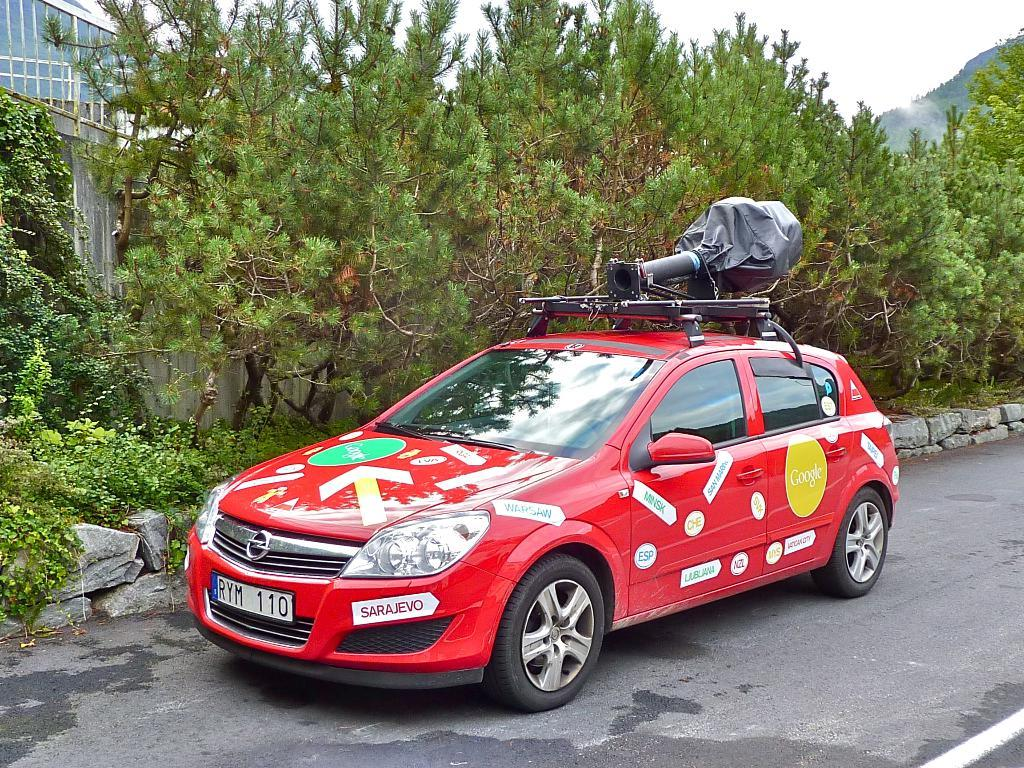What color is the car in the image? The car in the image is red. Where is the car located in the image? The car is on the road. What can be seen in the background of the image? There are trees and at least one building in the background of the image. What natural feature is visible to the right side of the image? There is a mountain visible to the right side of the image. What type of feeling can be seen on the car's face in the image? There is no face on the car in the image, as it is a vehicle and not a living being. 